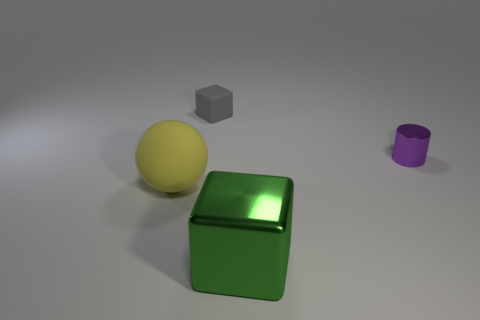What size is the matte thing that is in front of the tiny thing to the left of the purple object?
Your response must be concise. Large. Do the green block in front of the tiny cube and the yellow thing have the same material?
Your response must be concise. No. There is a shiny thing in front of the purple metallic object; what shape is it?
Your answer should be compact. Cube. What number of gray blocks have the same size as the purple metallic cylinder?
Your answer should be compact. 1. The green cube is what size?
Provide a short and direct response. Large. How many big blocks are in front of the green metallic cube?
Provide a succinct answer. 0. There is a green object that is made of the same material as the purple thing; what shape is it?
Your answer should be compact. Cube. Are there fewer purple things in front of the small shiny thing than big objects that are on the left side of the large green metal cube?
Give a very brief answer. Yes. Is the number of big green matte cylinders greater than the number of yellow matte things?
Make the answer very short. No. What is the tiny gray cube made of?
Ensure brevity in your answer.  Rubber. 